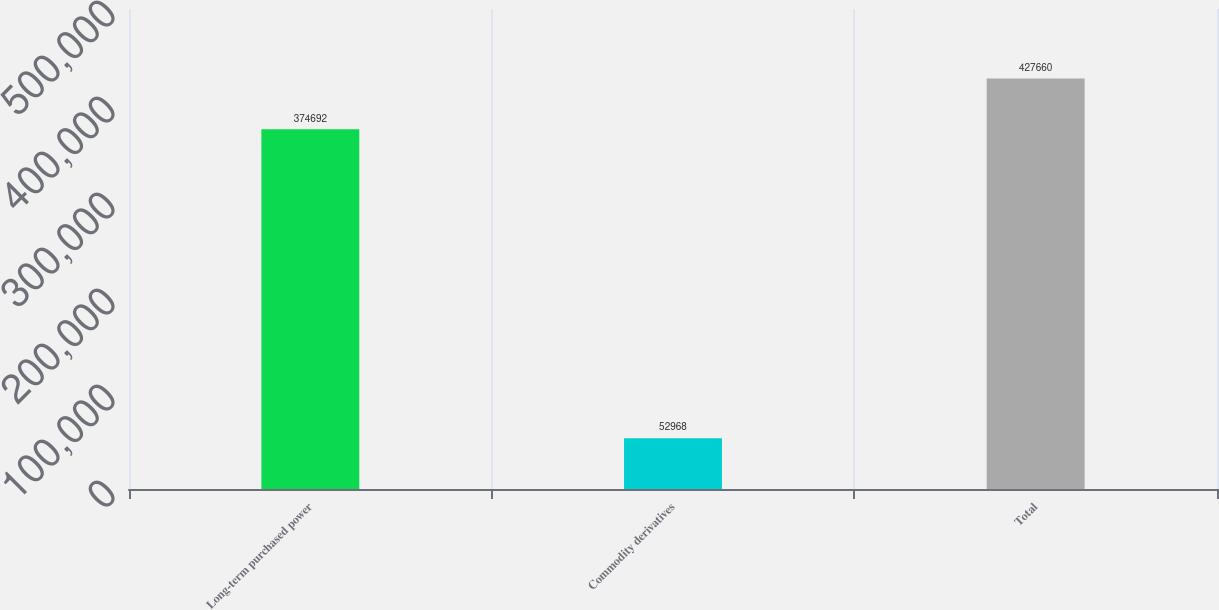Convert chart. <chart><loc_0><loc_0><loc_500><loc_500><bar_chart><fcel>Long-term purchased power<fcel>Commodity derivatives<fcel>Total<nl><fcel>374692<fcel>52968<fcel>427660<nl></chart> 